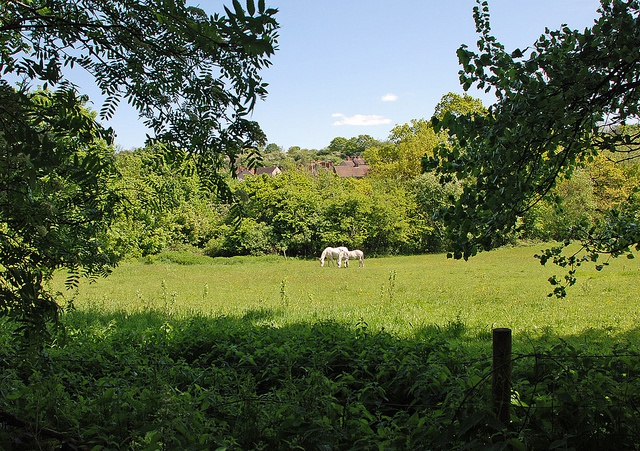Describe the objects in this image and their specific colors. I can see horse in black, ivory, olive, and tan tones and horse in black, white, olive, and tan tones in this image. 